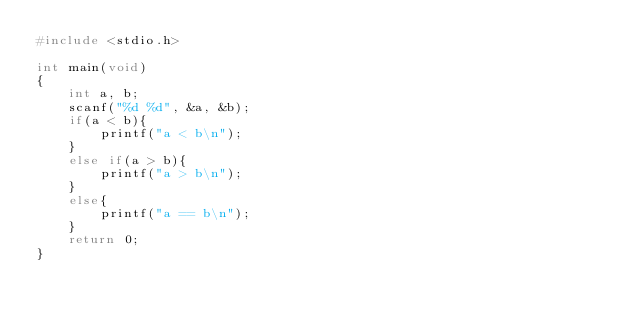Convert code to text. <code><loc_0><loc_0><loc_500><loc_500><_C_>#include <stdio.h>

int main(void)
{
	int a, b;
	scanf("%d %d", &a, &b);
	if(a < b){
		printf("a < b\n");
	}
	else if(a > b){
		printf("a > b\n");
	}
	else{
		printf("a == b\n");
	}
	return 0;
}</code> 